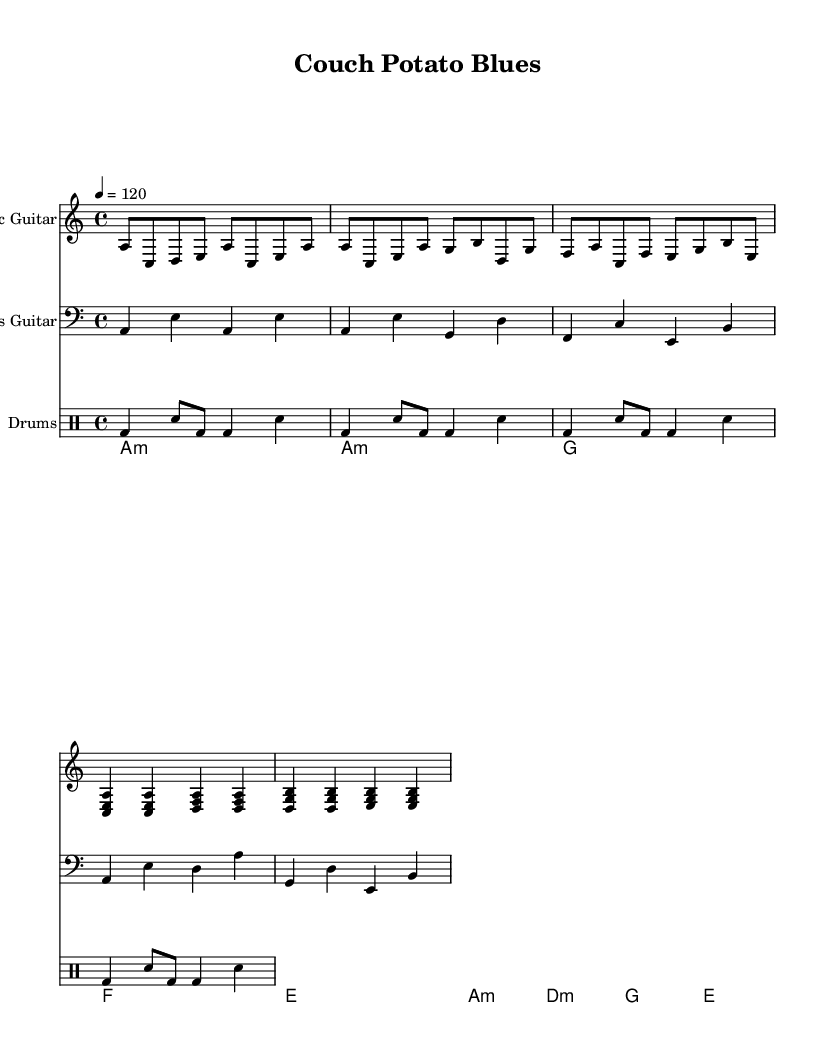What is the key signature of this music? The key signature is A minor, which contains no sharps or flats. This can be determined from the key indicated at the beginning of the stave.
Answer: A minor What is the time signature of the music? The time signature is 4/4, indicated at the start of each staff, signifying four beats per measure with a quarter note receiving one beat.
Answer: 4/4 What is the tempo of the piece? The tempo is indicated as 120 beats per minute, which is shown above the music. This tells the performer how fast to play the piece.
Answer: 120 What is the main chord in the verse section? The main chord in the verse section is A minor, which is the first chord played and establishes the tonality of the verse.
Answer: A minor How many measures are there in the chorus? There are four measures in the chorus, which can be counted by looking at the layout of the musical notes and the end bars that separate each measure.
Answer: 4 What type of rhythm is predominantly used in the drum section? The predominant rhythm is a shuffle pattern, which can be recognized by the specific pattern of bass drum and snare notes throughout the drum staff.
Answer: Shuffle Which instrument plays the main melody in this piece? The main melody is played by the electric guitar, which is indicated in the first staff with the clef and notes corresponding to the melodic line.
Answer: Electric Guitar 